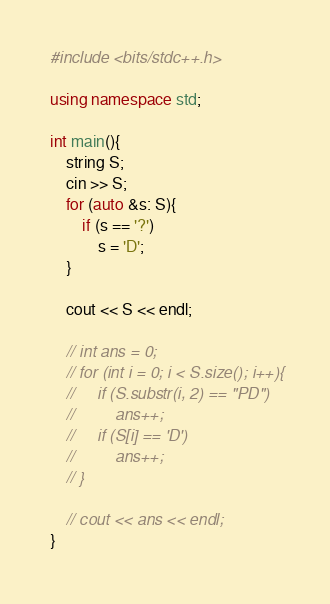<code> <loc_0><loc_0><loc_500><loc_500><_C++_>#include <bits/stdc++.h>

using namespace std;

int main(){
    string S;
    cin >> S;
    for (auto &s: S){
        if (s == '?')
            s = 'D';
    }

    cout << S << endl;

    // int ans = 0;
    // for (int i = 0; i < S.size(); i++){
    //     if (S.substr(i, 2) == "PD")
    //         ans++;
    //     if (S[i] == 'D')
    //         ans++;
    // }

    // cout << ans << endl;
}</code> 